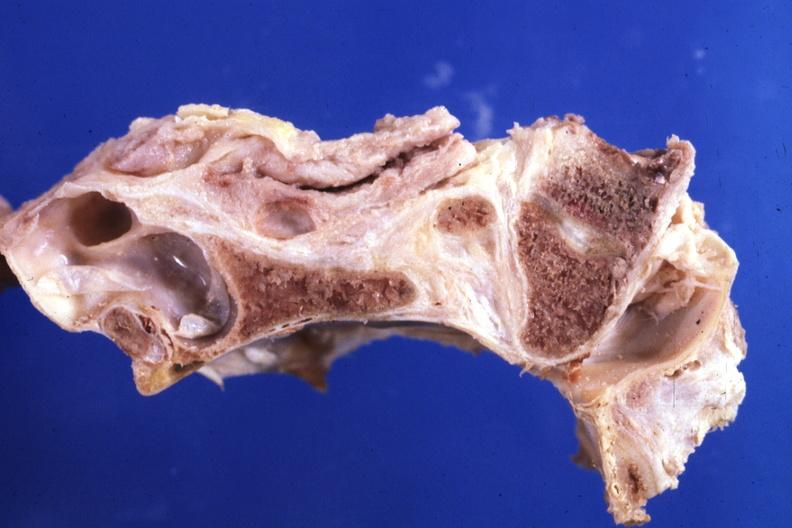s rheumatoid arthritis present?
Answer the question using a single word or phrase. Yes 